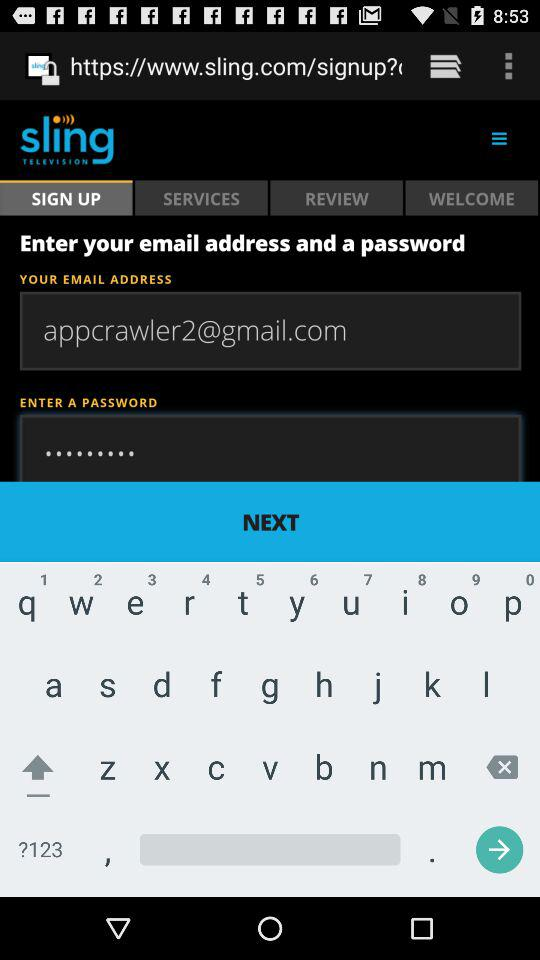How many channels are available with this plan?
Answer the question using a single word or phrase. 65+ 